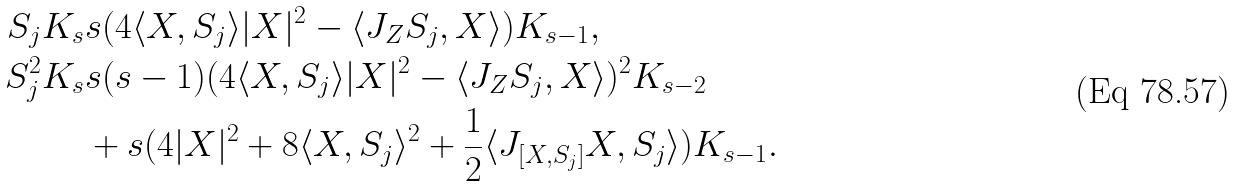Convert formula to latex. <formula><loc_0><loc_0><loc_500><loc_500>S _ { j } K _ { s } & s ( 4 \langle X , S _ { j } \rangle | X | ^ { 2 } - \langle J _ { Z } S _ { j } , X \rangle ) K _ { s - 1 } , \\ S _ { j } ^ { 2 } K _ { s } & s ( s - 1 ) ( 4 \langle X , S _ { j } \rangle | X | ^ { 2 } - \langle J _ { Z } S _ { j } , X \rangle ) ^ { 2 } K _ { s - 2 } \\ & + s ( 4 | X | ^ { 2 } + 8 \langle X , S _ { j } \rangle ^ { 2 } + \frac { 1 } { 2 } \langle J _ { [ X , S _ { j } ] } X , S _ { j } \rangle ) K _ { s - 1 } .</formula> 